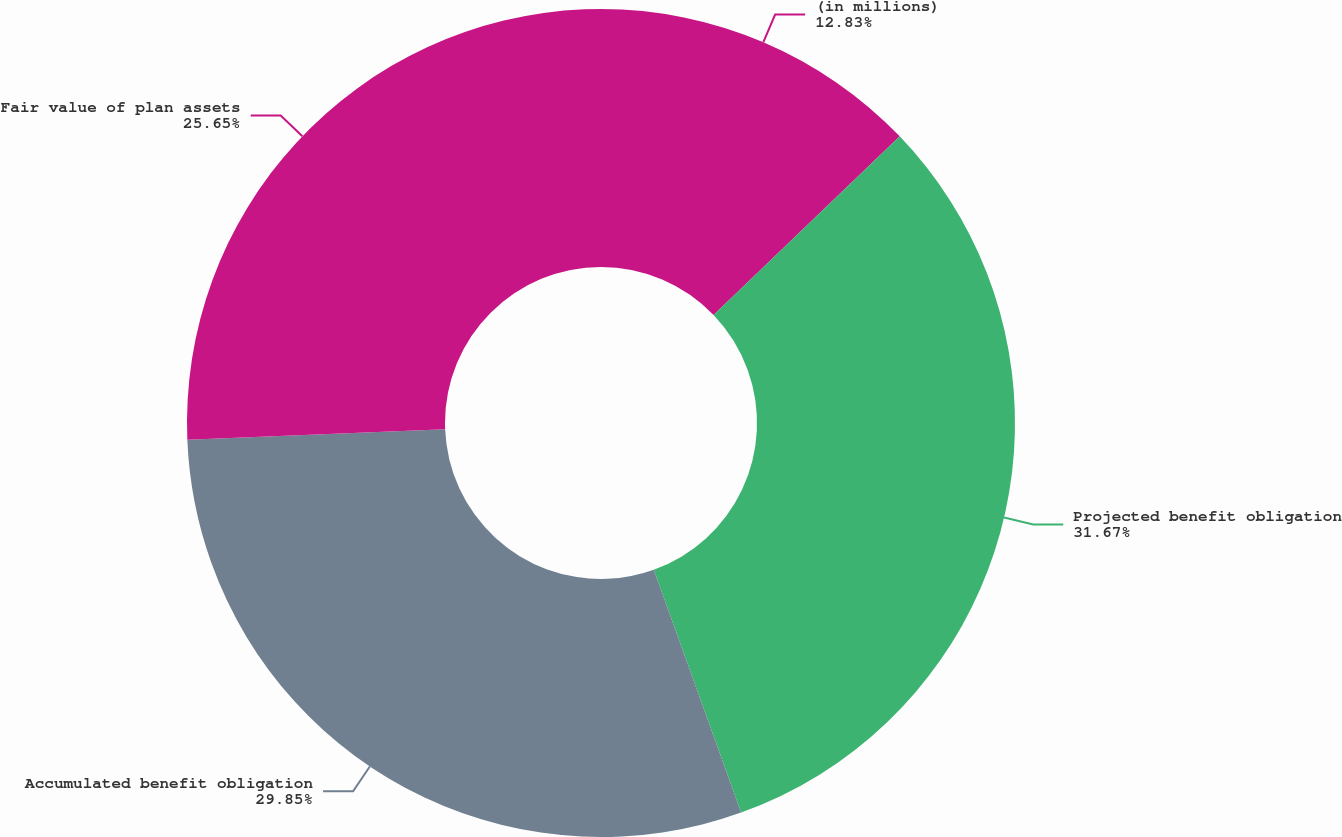<chart> <loc_0><loc_0><loc_500><loc_500><pie_chart><fcel>(in millions)<fcel>Projected benefit obligation<fcel>Accumulated benefit obligation<fcel>Fair value of plan assets<nl><fcel>12.83%<fcel>31.68%<fcel>29.85%<fcel>25.65%<nl></chart> 